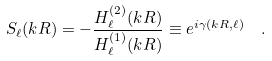<formula> <loc_0><loc_0><loc_500><loc_500>S _ { \ell } ( k R ) = - \frac { H _ { \ell } ^ { ( 2 ) } ( k R ) } { H _ { \ell } ^ { ( 1 ) } ( k R ) } \equiv e ^ { i \gamma ( k R , \ell ) } \ \ .</formula> 